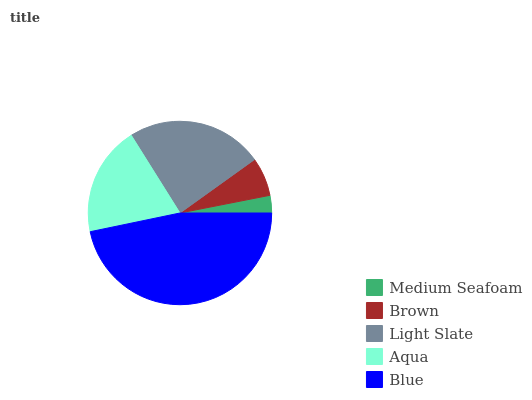Is Medium Seafoam the minimum?
Answer yes or no. Yes. Is Blue the maximum?
Answer yes or no. Yes. Is Brown the minimum?
Answer yes or no. No. Is Brown the maximum?
Answer yes or no. No. Is Brown greater than Medium Seafoam?
Answer yes or no. Yes. Is Medium Seafoam less than Brown?
Answer yes or no. Yes. Is Medium Seafoam greater than Brown?
Answer yes or no. No. Is Brown less than Medium Seafoam?
Answer yes or no. No. Is Aqua the high median?
Answer yes or no. Yes. Is Aqua the low median?
Answer yes or no. Yes. Is Light Slate the high median?
Answer yes or no. No. Is Medium Seafoam the low median?
Answer yes or no. No. 